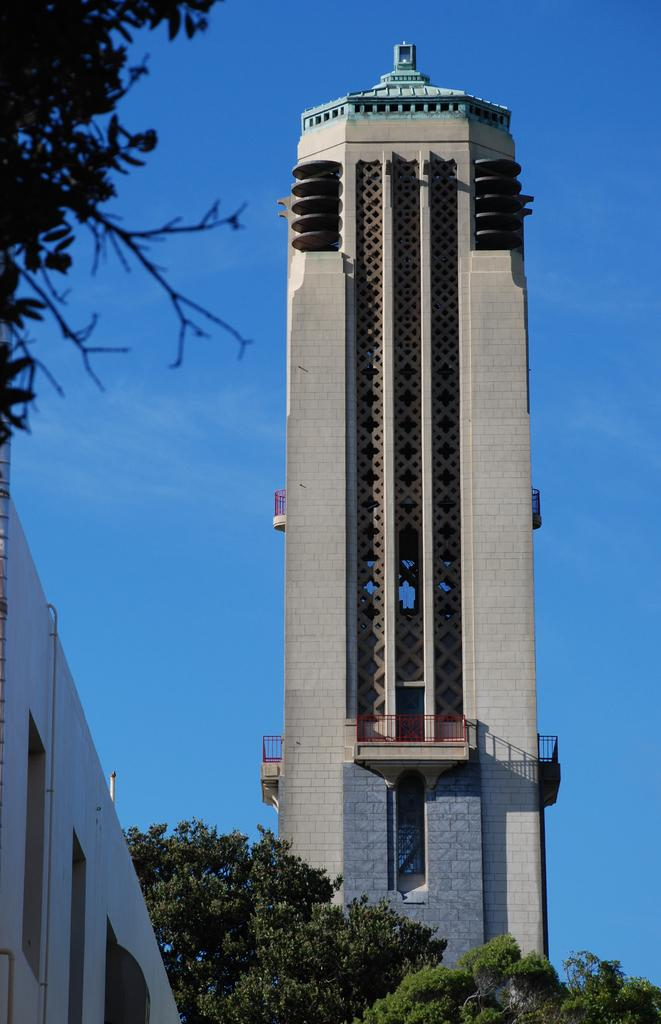What type of structure is in the image? There is a building tower in the image. What natural elements can be seen in the image? There are trees in the image. What is on the right side of the image? There is a wall on the right side of the image. What is visible in the background of the image? The sky is visible in the image. Can you see a hen wearing a crown in the image? There is no hen or crown present in the image. 